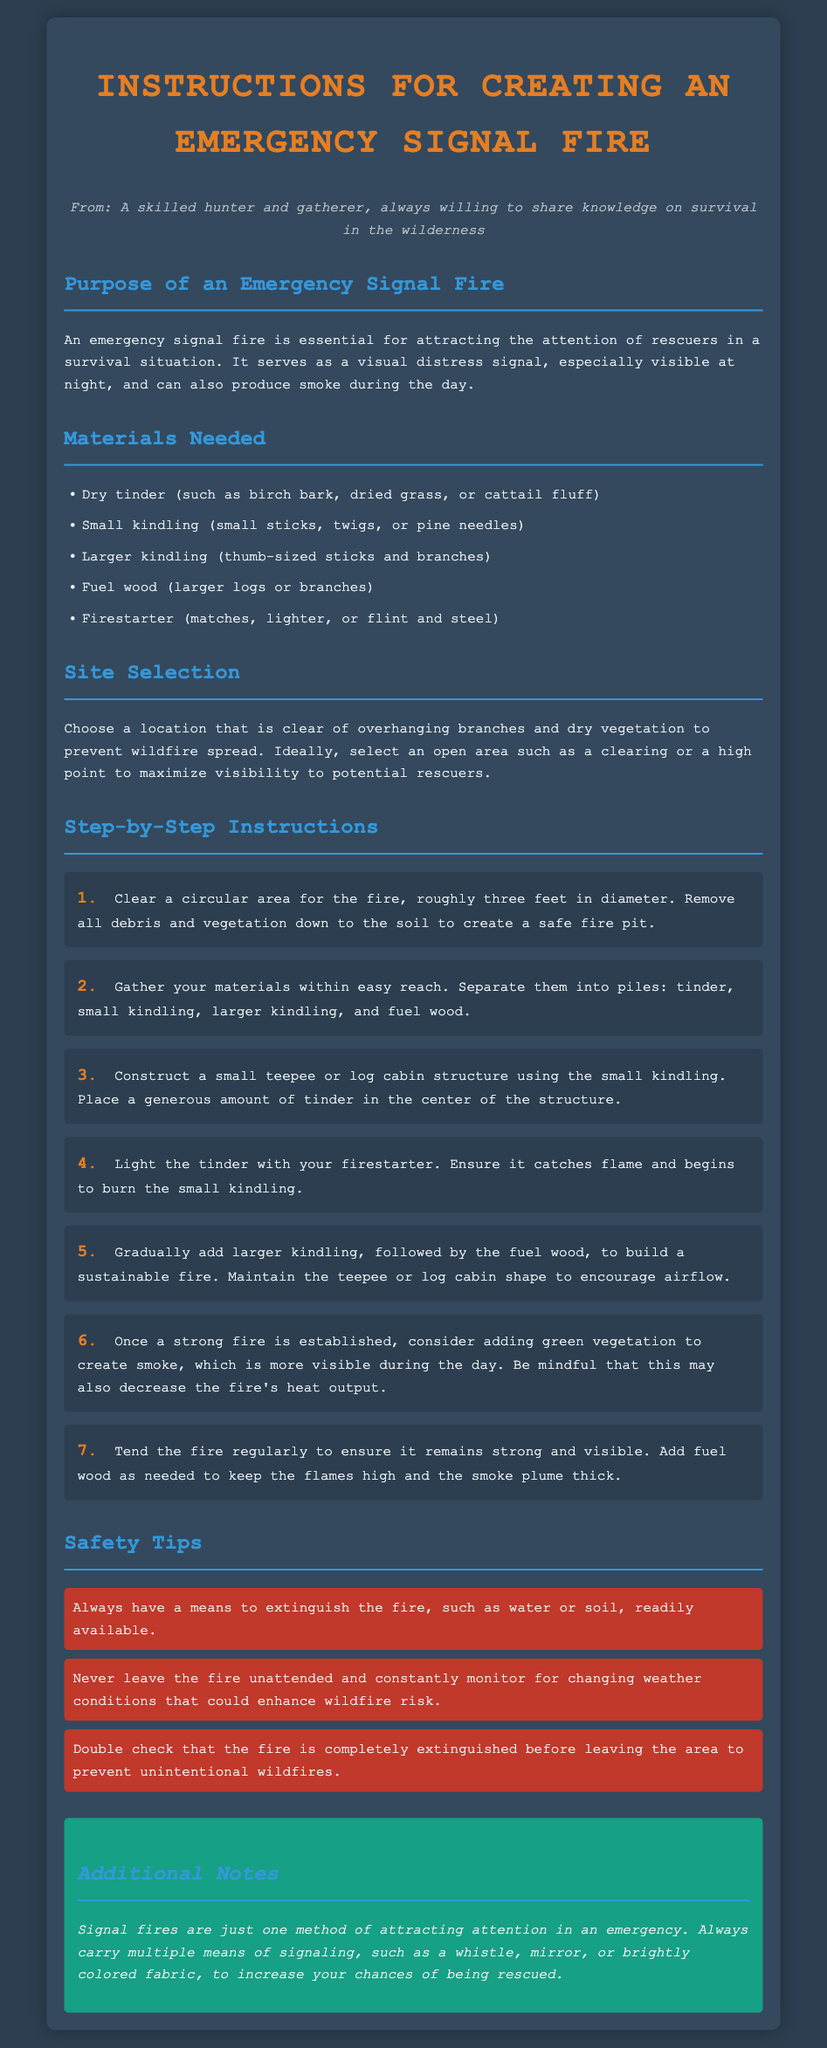What is the purpose of an emergency signal fire? The purpose of an emergency signal fire is to attract the attention of rescuers in a survival situation as a visual distress signal.
Answer: Attract attention of rescuers What are the materials needed for an emergency signal fire? The materials needed are listed in the document and include dry tinder, small kindling, larger kindling, fuel wood, and a firestarter.
Answer: Dry tinder, small kindling, larger kindling, fuel wood, firestarter How large should the cleared area be for the fire? The document specifies that the cleared area should be roughly three feet in diameter.
Answer: Three feet What should you consider adding to the fire once it is established? The document suggests adding green vegetation to create smoke for better visibility during the day.
Answer: Green vegetation What is one safety tip mentioned in the instructions? One safety tip is to always have a means to extinguish the fire readily available.
Answer: Have a means to extinguish the fire How many main steps are outlined in creating an emergency signal fire? The document lists seven steps in the process of creating an emergency signal fire.
Answer: Seven steps What is suggested to keep the fire sustainable? The materials need to be added gradually to maintain the fire, specifically larger kindling followed by fuel wood.
Answer: Gradually add larger kindling and fuel wood What shape should be maintained for better airflow? The document mentions maintaining a teepee or log cabin shape to encourage airflow.
Answer: Teepee or log cabin shape What additional means of signaling are recommended? The instructions advise carrying a whistle, mirror, or brightly colored fabric in addition to the signal fire.
Answer: Whistle, mirror, or brightly colored fabric 